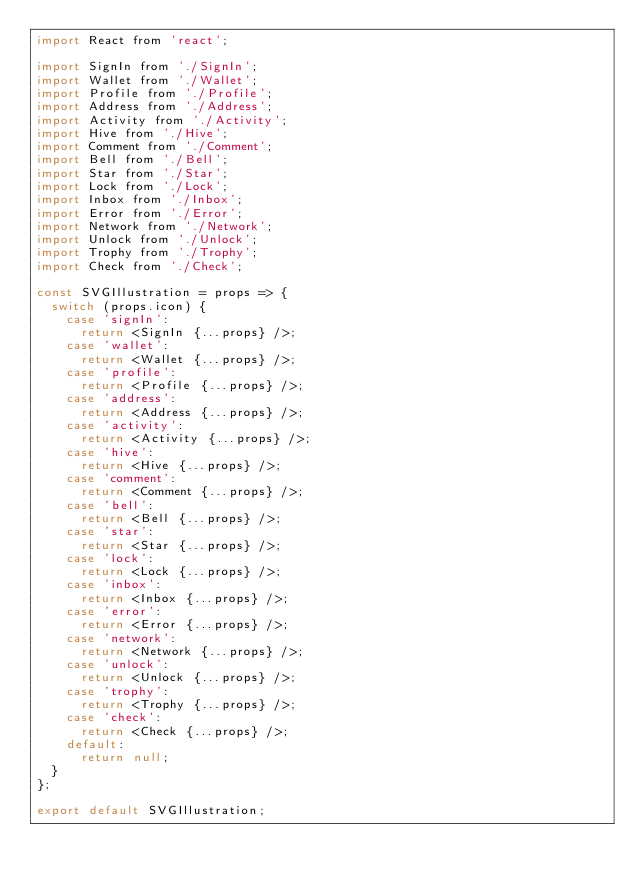Convert code to text. <code><loc_0><loc_0><loc_500><loc_500><_JavaScript_>import React from 'react';

import SignIn from './SignIn';
import Wallet from './Wallet';
import Profile from './Profile';
import Address from './Address';
import Activity from './Activity';
import Hive from './Hive';
import Comment from './Comment';
import Bell from './Bell';
import Star from './Star';
import Lock from './Lock';
import Inbox from './Inbox';
import Error from './Error';
import Network from './Network';
import Unlock from './Unlock';
import Trophy from './Trophy';
import Check from './Check';

const SVGIllustration = props => {
  switch (props.icon) {
    case 'signIn':
      return <SignIn {...props} />;
    case 'wallet':
      return <Wallet {...props} />;
    case 'profile':
      return <Profile {...props} />;
    case 'address':
      return <Address {...props} />;
    case 'activity':
      return <Activity {...props} />;
    case 'hive':
      return <Hive {...props} />;
    case 'comment':
      return <Comment {...props} />;
    case 'bell':
      return <Bell {...props} />;
    case 'star':
      return <Star {...props} />;
    case 'lock':
      return <Lock {...props} />;
    case 'inbox':
      return <Inbox {...props} />;
    case 'error':
      return <Error {...props} />;
    case 'network':
      return <Network {...props} />;
    case 'unlock':
      return <Unlock {...props} />;
    case 'trophy':
      return <Trophy {...props} />;
    case 'check':
      return <Check {...props} />;
    default:
      return null;
  }
};

export default SVGIllustration;
</code> 